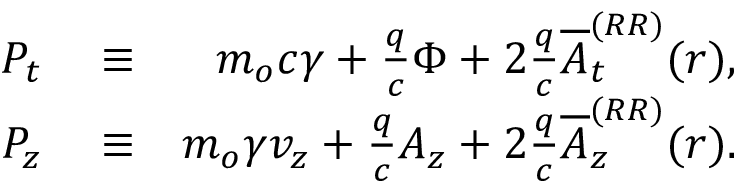Convert formula to latex. <formula><loc_0><loc_0><loc_500><loc_500>\begin{array} { r l r } { P _ { t } } & \equiv } & { m _ { o } c \gamma + \frac { q } { c } \Phi + 2 \frac { q } { c } \overline { A } _ { t } ^ { ( R R ) } ( r ) , } \\ { P _ { z } } & \equiv } & { m _ { o } \gamma v _ { z } + \frac { q } { c } A _ { z } + 2 \frac { q } { c } \overline { A } _ { z } ^ { ( R R ) } ( r ) . } \end{array}</formula> 